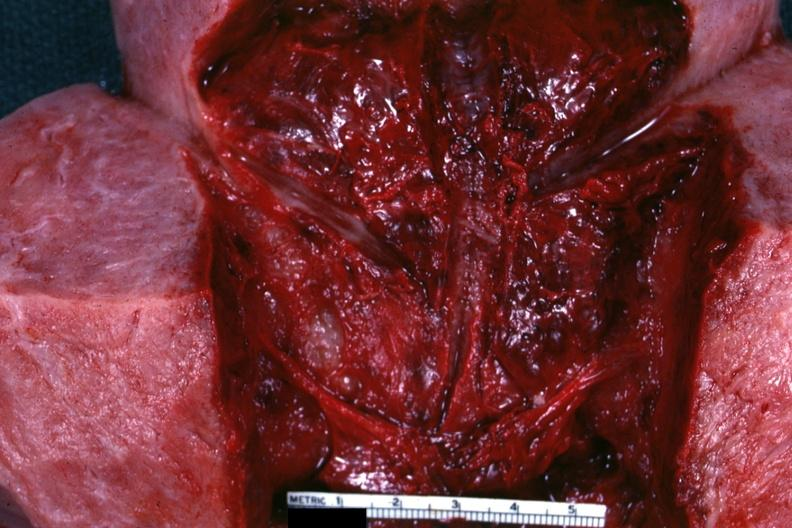what does this image show?
Answer the question using a single word or phrase. Close-up view of endometrial surface 18 hours after a cesarean section 